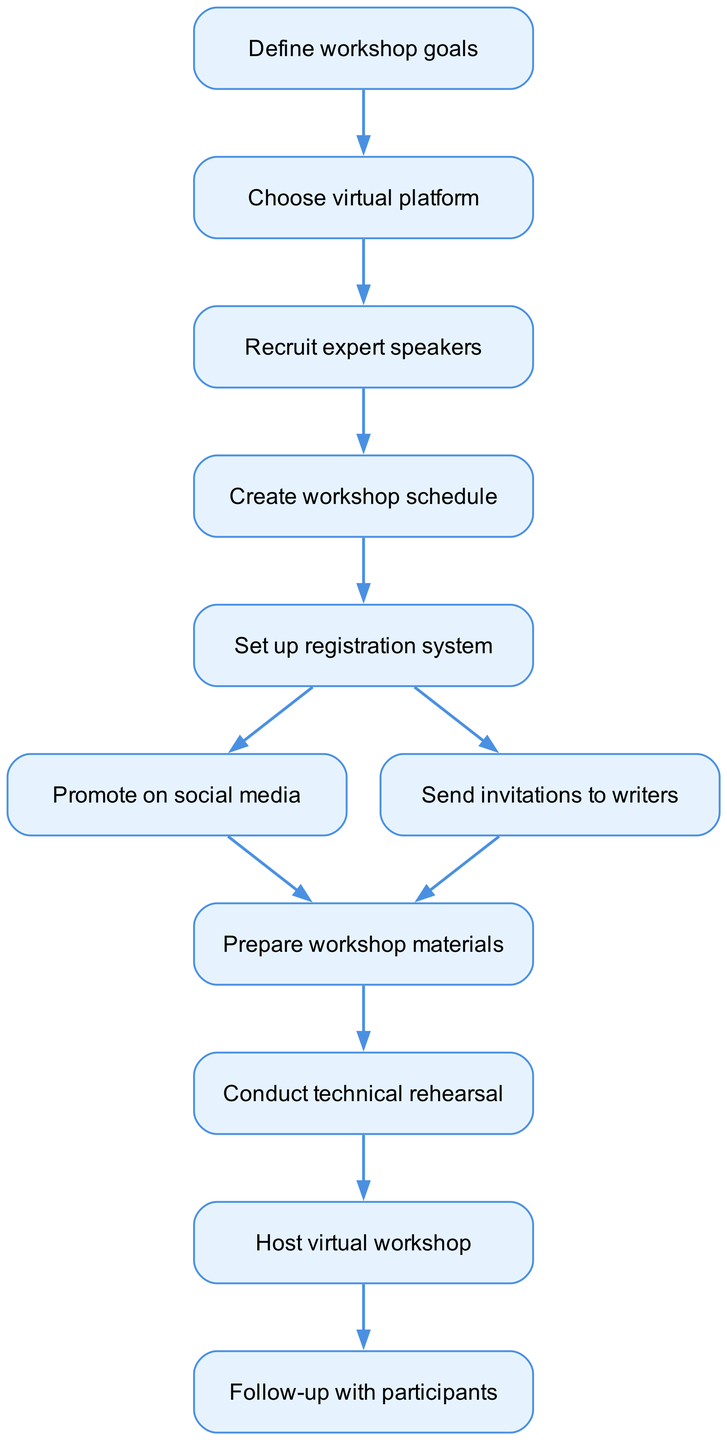What is the first step in the flowchart? The first node in the flowchart is "Define workshop goals", which indicates the initial action to be taken. It's connected to the next step as well.
Answer: Define workshop goals How many nodes are present in the diagram? By counting, we see there are 11 distinct nodes listed in the flowchart, each representing an action or step in the process.
Answer: 11 Which step comes after "Create workshop schedule"? The node that follows "Create workshop schedule" is "Set up registration system", indicating the sequential action that needs to be taken next.
Answer: Set up registration system How many edges connect to the "Set up registration system" node? The edges connecting to "Set up registration system" come from the "Create workshop schedule" node and lead to two other nodes: "Promote on social media" and "Send invitations to writers". This totals three edges.
Answer: 3 What is the last action in the flowchart? The final step in the flowchart is "Follow-up with participants", which signifies the completion of the workshop process.
Answer: Follow-up with participants Which two nodes are directly connected to "Promote on social media"? The two nodes that follow "Promote on social media" are "Prepare workshop materials" and it is only connected by arrows coming from the "Set up registration system" node.
Answer: Prepare workshop materials What is the relationship between "Recruit expert speakers" and "Conduct technical rehearsal"? "Recruit expert speakers" is the third step and directly precedes the "Create workshop schedule", which then leads to "Prepare workshop materials", and "Conduct technical rehearsal" is the ninth step that follows preparation steps.
Answer: They are sequential steps in the process What action follows "Host virtual workshop"? The action that comes immediately after "Host virtual workshop" is "Follow-up with participants", as it is the next and final step in the process flow.
Answer: Follow-up with participants 